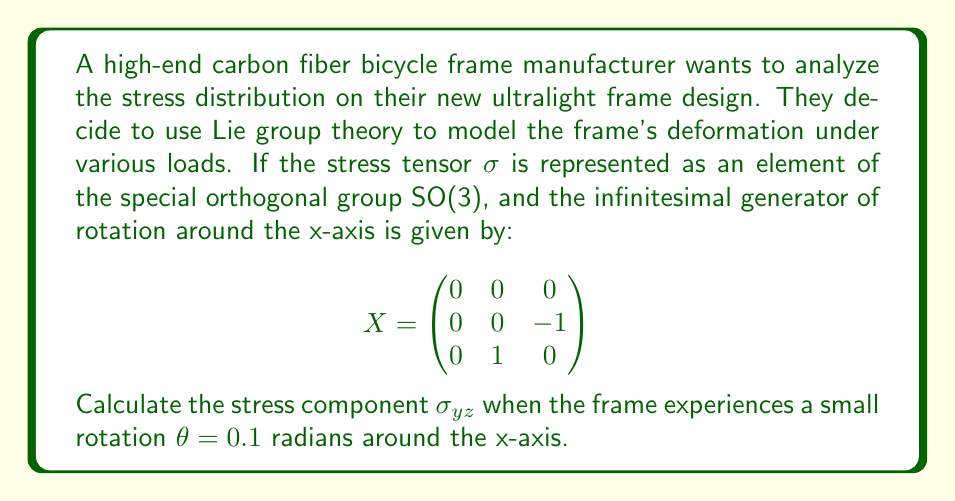Can you answer this question? To solve this problem, we'll follow these steps:

1) In Lie group theory, elements of SO(3) can be expressed using the exponential map:

   $$\sigma = e^{\theta X}$$

   where $\theta$ is the rotation angle and $X$ is the infinitesimal generator.

2) For small rotations, we can approximate the exponential map using the first two terms of its Taylor series:

   $$e^{\theta X} \approx I + \theta X$$

   where $I$ is the 3x3 identity matrix.

3) Let's calculate $\theta X$:

   $$\theta X = 0.1 \begin{pmatrix}
   0 & 0 & 0 \\
   0 & 0 & -1 \\
   0 & 1 & 0
   \end{pmatrix} = \begin{pmatrix}
   0 & 0 & 0 \\
   0 & 0 & -0.1 \\
   0 & 0.1 & 0
   \end{pmatrix}$$

4) Now, let's add this to the identity matrix:

   $$\sigma \approx I + \theta X = \begin{pmatrix}
   1 & 0 & 0 \\
   0 & 1 & 0 \\
   0 & 0 & 1
   \end{pmatrix} + \begin{pmatrix}
   0 & 0 & 0 \\
   0 & 0 & -0.1 \\
   0 & 0.1 & 0
   \end{pmatrix} = \begin{pmatrix}
   1 & 0 & 0 \\
   0 & 1 & -0.1 \\
   0 & 0.1 & 1
   \end{pmatrix}$$

5) The stress component $\sigma_{yz}$ is the element in the second row, third column of this matrix.
Answer: $\sigma_{yz} = -0.1$ 